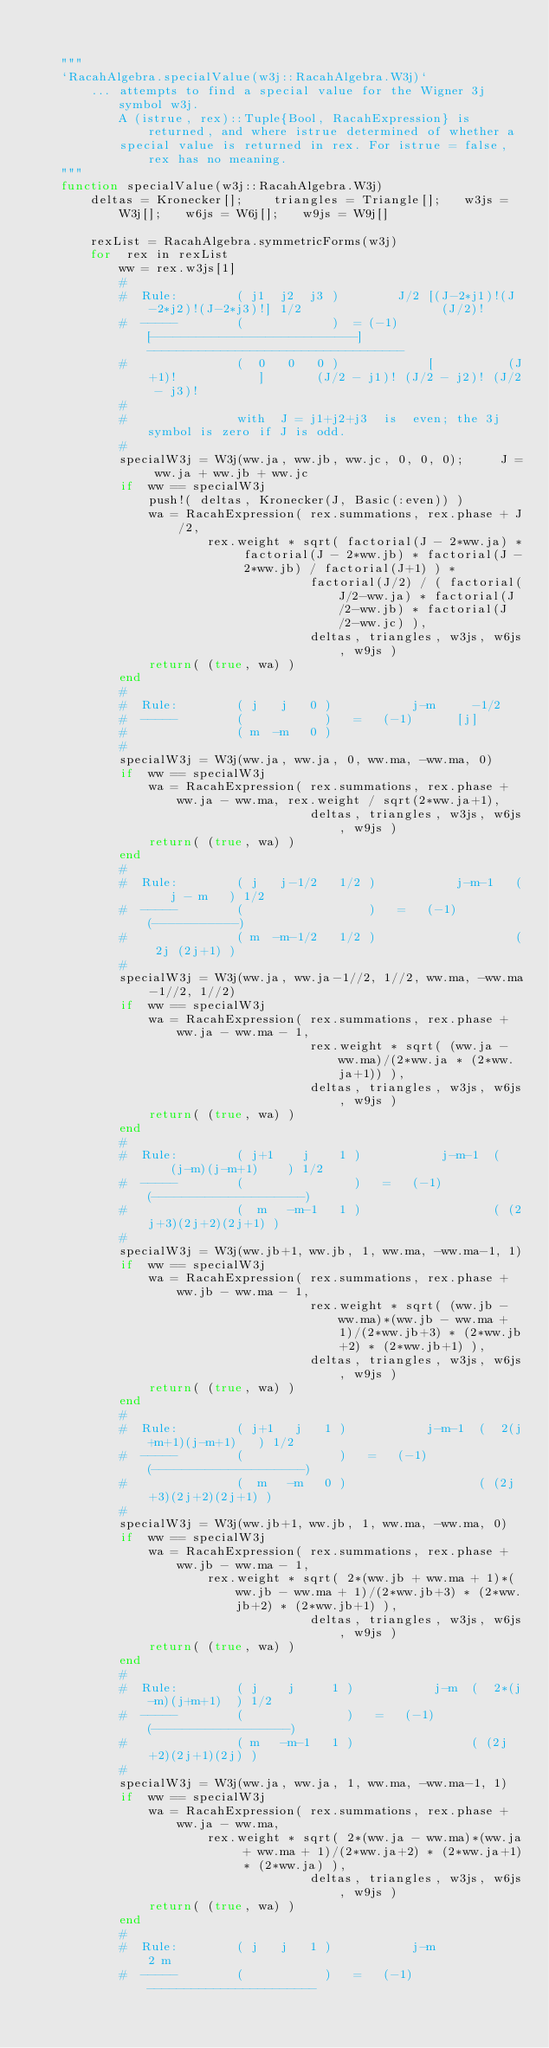<code> <loc_0><loc_0><loc_500><loc_500><_Julia_>
    
    """
    `RacahAlgebra.specialValue(w3j::RacahAlgebra.W3j)`  
        ... attempts to find a special value for the Wigner 3j symbol w3j. 
            A (istrue, rex)::Tuple{Bool, RacahExpression} is returned, and where istrue determined of whether a 
            special value is returned in rex. For istrue = false, rex has no meaning.
    """
    function specialValue(w3j::RacahAlgebra.W3j)
        deltas = Kronecker[];    triangles = Triangle[];   w3js = W3j[];   w6js = W6j[];   w9js = W9j[]

        rexList = RacahAlgebra.symmetricForms(w3j)
        for  rex in rexList
            ww = rex.w3js[1]
            #
            #  Rule:        ( j1  j2  j3 )        J/2 [(J-2*j1)!(J-2*j2)!(J-2*j3)!] 1/2                   (J/2)!
            #  -----        (            )  = (-1)    [---------------------------]       -----------------------------------
            #               (  0   0   0 )            [          (J+1)!           ]       (J/2 - j1)! (J/2 - j2)! (J/2 - j3)!
            #
            #               with  J = j1+j2+j3  is  even; the 3j symbol is zero if J is odd.
            #
            specialW3j = W3j(ww.ja, ww.jb, ww.jc, 0, 0, 0);     J = ww.ja + ww.jb + ww.jc
            if  ww == specialW3j
                push!( deltas, Kronecker(J, Basic(:even)) )
                wa = RacahExpression( rex.summations, rex.phase + J/2, 
                        rex.weight * sqrt( factorial(J - 2*ww.ja) * factorial(J - 2*ww.jb) * factorial(J - 2*ww.jb) / factorial(J+1) ) * 
                                      factorial(J/2) / ( factorial(J/2-ww.ja) * factorial(J/2-ww.jb) * factorial(J/2-ww.jc) ), 
                                      deltas, triangles, w3js, w6js, w9js ) 
                return( (true, wa) )
            end
            #
            #  Rule:        ( j   j   0 )           j-m     -1/2
            #  -----        (           )   =   (-1)      [j]
            #               ( m  -m   0 )
            #
            specialW3j = W3j(ww.ja, ww.ja, 0, ww.ma, -ww.ma, 0)
            if  ww == specialW3j
                wa = RacahExpression( rex.summations, rex.phase + ww.ja - ww.ma, rex.weight / sqrt(2*ww.ja+1), 
                                      deltas, triangles, w3js, w6js, w9js ) 
                return( (true, wa) )
            end
            #
            #  Rule:        ( j   j-1/2   1/2 )           j-m-1   (   j - m   ) 1/2
            #  -----        (                 )   =   (-1)        (-----------)
            #               ( m  -m-1/2   1/2 )                   ( 2j (2j+1) )
            #
            specialW3j = W3j(ww.ja, ww.ja-1//2, 1//2, ww.ma, -ww.ma-1//2, 1//2)
            if  ww == specialW3j
                wa = RacahExpression( rex.summations, rex.phase + ww.ja - ww.ma - 1, 
                                      rex.weight * sqrt( (ww.ja - ww.ma)/(2*ww.ja * (2*ww.ja+1)) ), 
                                      deltas, triangles, w3js, w6js, w9js ) 
                return( (true, wa) )
            end
            #
            #  Rule:        ( j+1    j    1 )           j-m-1  (    (j-m)(j-m+1)    ) 1/2
            #  -----        (               )   =   (-1)       (--------------------)
            #               (  m   -m-1   1 )                  ( (2j+3)(2j+2)(2j+1) )
            #
            specialW3j = W3j(ww.jb+1, ww.jb, 1, ww.ma, -ww.ma-1, 1)
            if  ww == specialW3j
                wa = RacahExpression( rex.summations, rex.phase + ww.jb - ww.ma - 1, 
                                      rex.weight * sqrt( (ww.jb - ww.ma)*(ww.jb - ww.ma + 1)/(2*ww.jb+3) * (2*ww.jb+2) * (2*ww.jb+1) ), 
                                      deltas, triangles, w3js, w6js, w9js ) 
                return( (true, wa) )
            end
            #
            #  Rule:        ( j+1   j   1 )           j-m-1  (  2(j+m+1)(j-m+1)   ) 1/2
            #  -----        (             )   =   (-1)       (--------------------)
            #               (  m   -m   0 )                  ( (2j+3)(2j+2)(2j+1) )
            #
            specialW3j = W3j(ww.jb+1, ww.jb, 1, ww.ma, -ww.ma, 0)
            if  ww == specialW3j
                wa = RacahExpression( rex.summations, rex.phase + ww.jb - ww.ma - 1, 
                        rex.weight * sqrt( 2*(ww.jb + ww.ma + 1)*(ww.jb - ww.ma + 1)/(2*ww.jb+3) * (2*ww.jb+2) * (2*ww.jb+1) ), 
                                      deltas, triangles, w3js, w6js, w9js ) 
                return( (true, wa) )
            end
            #
            #  Rule:        ( j    j     1 )           j-m  (  2*(j-m)(j+m+1)  ) 1/2
            #  -----        (              )   =   (-1)     (------------------)
            #               ( m   -m-1   1 )                ( (2j+2)(2j+1)(2j) )
            #
            specialW3j = W3j(ww.ja, ww.ja, 1, ww.ma, -ww.ma-1, 1)
            if  ww == specialW3j
                wa = RacahExpression( rex.summations, rex.phase + ww.ja - ww.ma, 
                        rex.weight * sqrt( 2*(ww.ja - ww.ma)*(ww.ja + ww.ma + 1)/(2*ww.ja+2) * (2*ww.ja+1) * (2*ww.ja) ), 
                                      deltas, triangles, w3js, w6js, w9js ) 
                return( (true, wa) )
            end
            #
            #  Rule:        ( j   j   1 )           j-m            2 m
            #  -----        (           )   =   (-1)      -----------------------</code> 